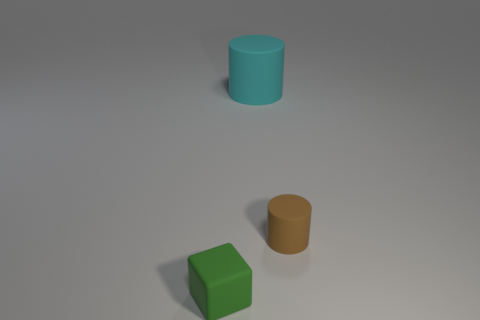Add 3 brown metal things. How many objects exist? 6 Subtract all cylinders. How many objects are left? 1 Subtract 1 cylinders. How many cylinders are left? 1 Add 1 rubber cylinders. How many rubber cylinders exist? 3 Subtract 0 yellow balls. How many objects are left? 3 Subtract all yellow blocks. Subtract all red cylinders. How many blocks are left? 1 Subtract all large gray matte cylinders. Subtract all large rubber objects. How many objects are left? 2 Add 3 tiny green objects. How many tiny green objects are left? 4 